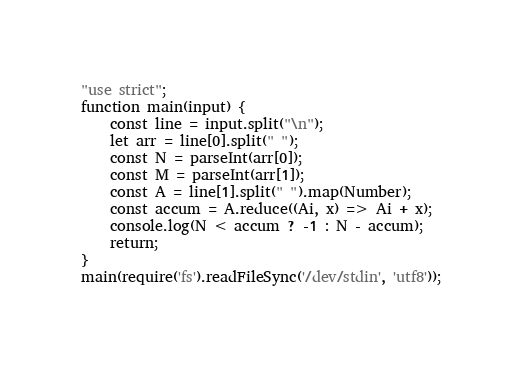Convert code to text. <code><loc_0><loc_0><loc_500><loc_500><_JavaScript_>"use strict";
function main(input) {
    const line = input.split("\n");
    let arr = line[0].split(" ");
    const N = parseInt(arr[0]);
    const M = parseInt(arr[1]);
    const A = line[1].split(" ").map(Number);
    const accum = A.reduce((Ai, x) => Ai + x);
    console.log(N < accum ? -1 : N - accum);
    return;
}
main(require('fs').readFileSync('/dev/stdin', 'utf8'));</code> 